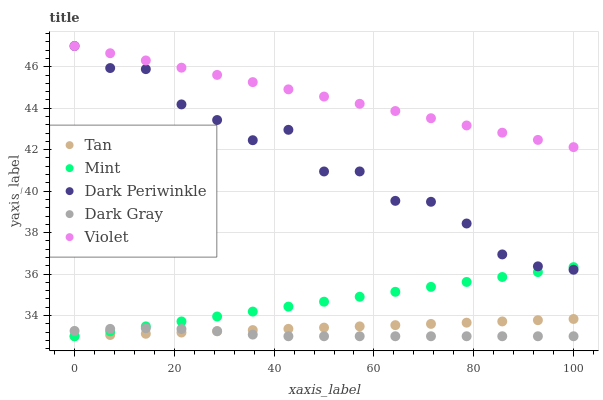Does Dark Gray have the minimum area under the curve?
Answer yes or no. Yes. Does Violet have the maximum area under the curve?
Answer yes or no. Yes. Does Tan have the minimum area under the curve?
Answer yes or no. No. Does Tan have the maximum area under the curve?
Answer yes or no. No. Is Violet the smoothest?
Answer yes or no. Yes. Is Dark Periwinkle the roughest?
Answer yes or no. Yes. Is Tan the smoothest?
Answer yes or no. No. Is Tan the roughest?
Answer yes or no. No. Does Dark Gray have the lowest value?
Answer yes or no. Yes. Does Dark Periwinkle have the lowest value?
Answer yes or no. No. Does Violet have the highest value?
Answer yes or no. Yes. Does Tan have the highest value?
Answer yes or no. No. Is Dark Gray less than Dark Periwinkle?
Answer yes or no. Yes. Is Dark Periwinkle greater than Dark Gray?
Answer yes or no. Yes. Does Dark Periwinkle intersect Violet?
Answer yes or no. Yes. Is Dark Periwinkle less than Violet?
Answer yes or no. No. Is Dark Periwinkle greater than Violet?
Answer yes or no. No. Does Dark Gray intersect Dark Periwinkle?
Answer yes or no. No. 